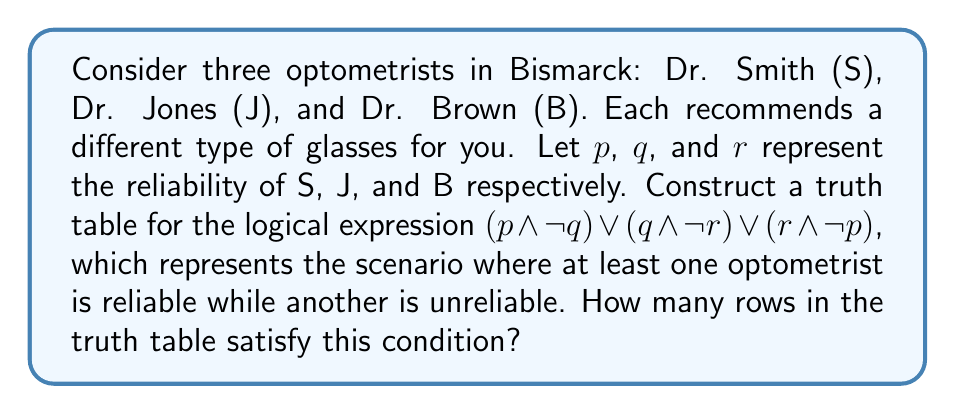Show me your answer to this math problem. Let's approach this step-by-step:

1) First, we need to construct a truth table with 3 variables (p, q, r), which means we'll have $2^3 = 8$ rows.

2) Let's create the truth table:

   $$
   \begin{array}{|c|c|c|c|c|c|c|}
   \hline
   p & q & r & p \land \neg q & q \land \neg r & r \land \neg p & (p \land \neg q) \lor (q \land \neg r) \lor (r \land \neg p) \\
   \hline
   0 & 0 & 0 & 0 & 0 & 0 & 0 \\
   0 & 0 & 1 & 0 & 0 & 1 & 1 \\
   0 & 1 & 0 & 0 & 1 & 0 & 1 \\
   0 & 1 & 1 & 0 & 0 & 1 & 1 \\
   1 & 0 & 0 & 1 & 0 & 0 & 1 \\
   1 & 0 & 1 & 1 & 0 & 0 & 1 \\
   1 & 1 & 0 & 0 & 1 & 0 & 1 \\
   1 & 1 & 1 & 0 & 0 & 0 & 0 \\
   \hline
   \end{array}
   $$

3) Now, we need to count the number of rows where the final column is 1.

4) Counting these rows, we find that there are 6 rows where the expression is true.

This result indicates that in 6 out of 8 possible scenarios, at least one optometrist is reliable while another is unreliable, which might reinforce the skepticism towards optometrists.
Answer: 6 